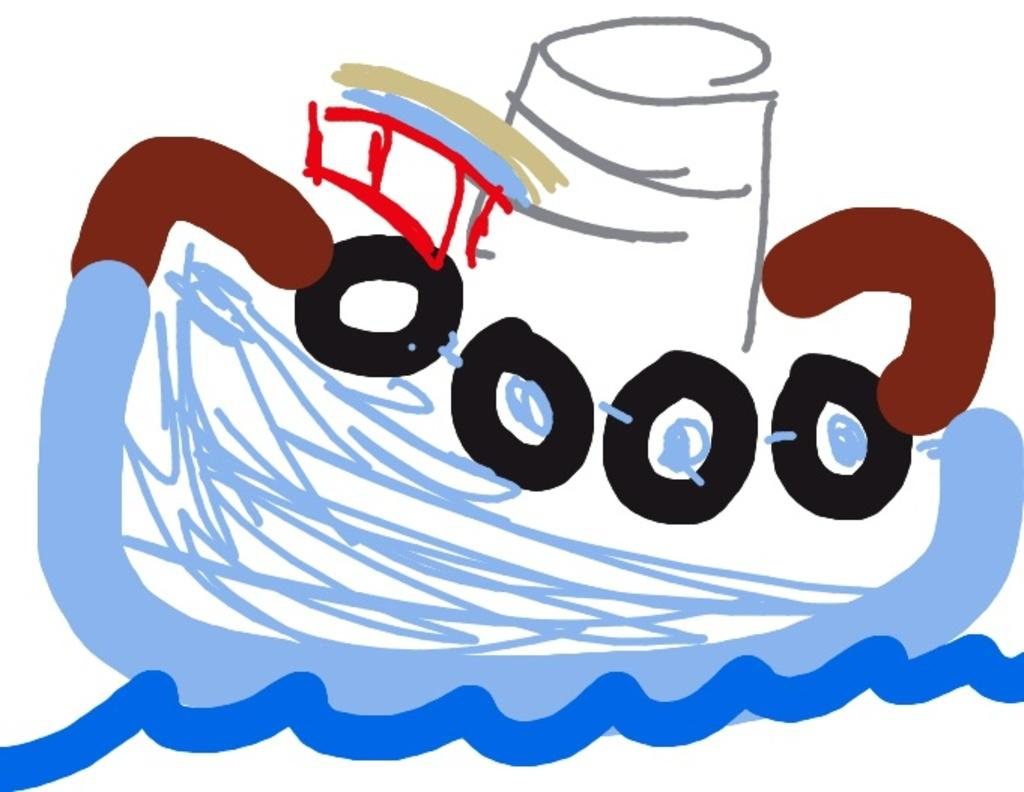What is the main subject in the image? There is a painting in the image. What is the color of the surface on which the painting is placed? The painting is on a white surface. What type of lace can be seen on the painting in the image? There is no lace present on the painting in the image. What type of cup is depicted in the painting? The image does not show a cup, as it only features a painting on a white surface. 